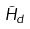<formula> <loc_0><loc_0><loc_500><loc_500>\tilde { H } _ { d }</formula> 